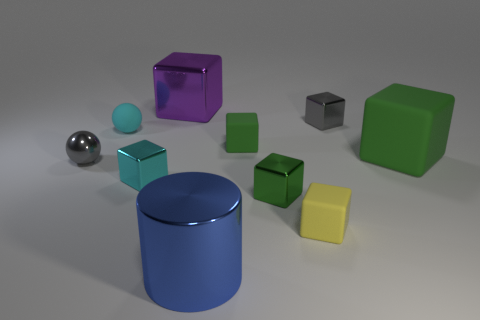Subtract all green cubes. How many were subtracted if there are1green cubes left? 2 Subtract all gray cylinders. How many green cubes are left? 3 Subtract 2 blocks. How many blocks are left? 5 Subtract all cyan metallic blocks. How many blocks are left? 6 Subtract all green blocks. How many blocks are left? 4 Subtract all blue blocks. Subtract all cyan spheres. How many blocks are left? 7 Subtract all spheres. How many objects are left? 8 Add 3 yellow rubber cubes. How many yellow rubber cubes exist? 4 Subtract 1 gray cubes. How many objects are left? 9 Subtract all big green matte blocks. Subtract all tiny metal objects. How many objects are left? 5 